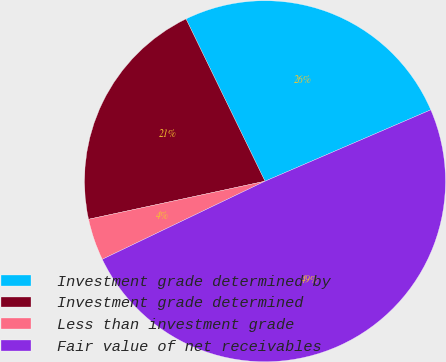Convert chart to OTSL. <chart><loc_0><loc_0><loc_500><loc_500><pie_chart><fcel>Investment grade determined by<fcel>Investment grade determined<fcel>Less than investment grade<fcel>Fair value of net receivables<nl><fcel>25.74%<fcel>21.17%<fcel>3.74%<fcel>49.35%<nl></chart> 